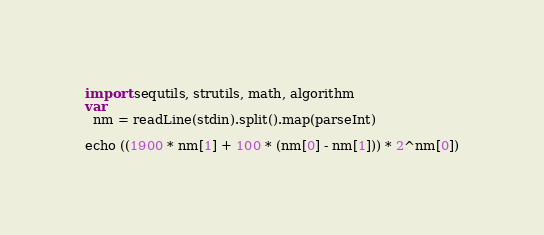Convert code to text. <code><loc_0><loc_0><loc_500><loc_500><_Nim_>import sequtils, strutils, math, algorithm
var
  nm = readLine(stdin).split().map(parseInt)

echo ((1900 * nm[1] + 100 * (nm[0] - nm[1])) * 2^nm[0])</code> 